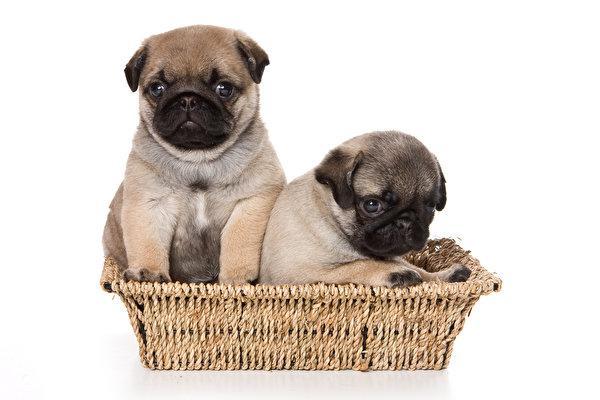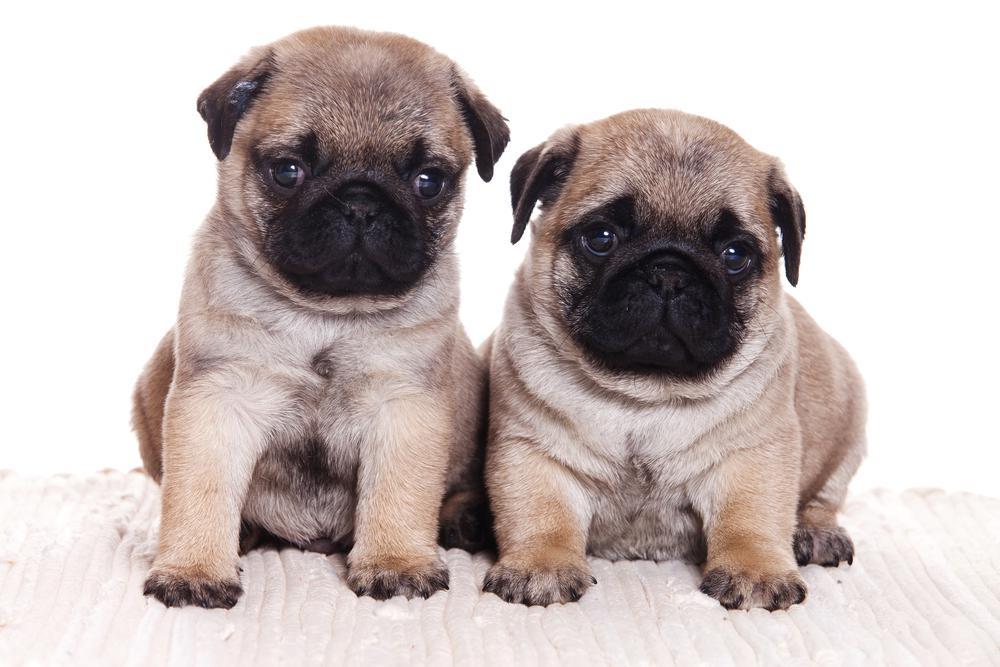The first image is the image on the left, the second image is the image on the right. Examine the images to the left and right. Is the description "There are atleast 4 pugs total." accurate? Answer yes or no. Yes. The first image is the image on the left, the second image is the image on the right. Given the left and right images, does the statement "A human hand can be seen touching one puppy." hold true? Answer yes or no. No. 